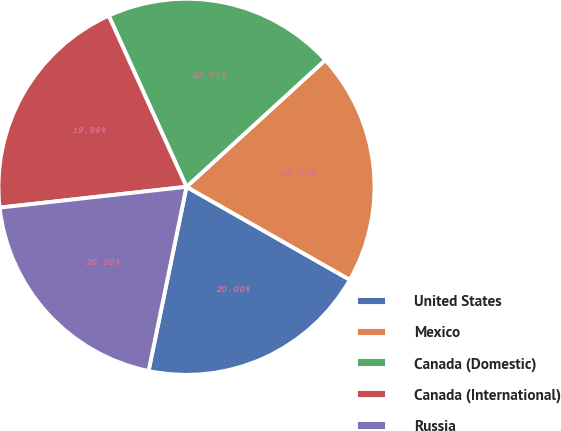<chart> <loc_0><loc_0><loc_500><loc_500><pie_chart><fcel>United States<fcel>Mexico<fcel>Canada (Domestic)<fcel>Canada (International)<fcel>Russia<nl><fcel>20.0%<fcel>20.02%<fcel>20.01%<fcel>19.98%<fcel>20.0%<nl></chart> 